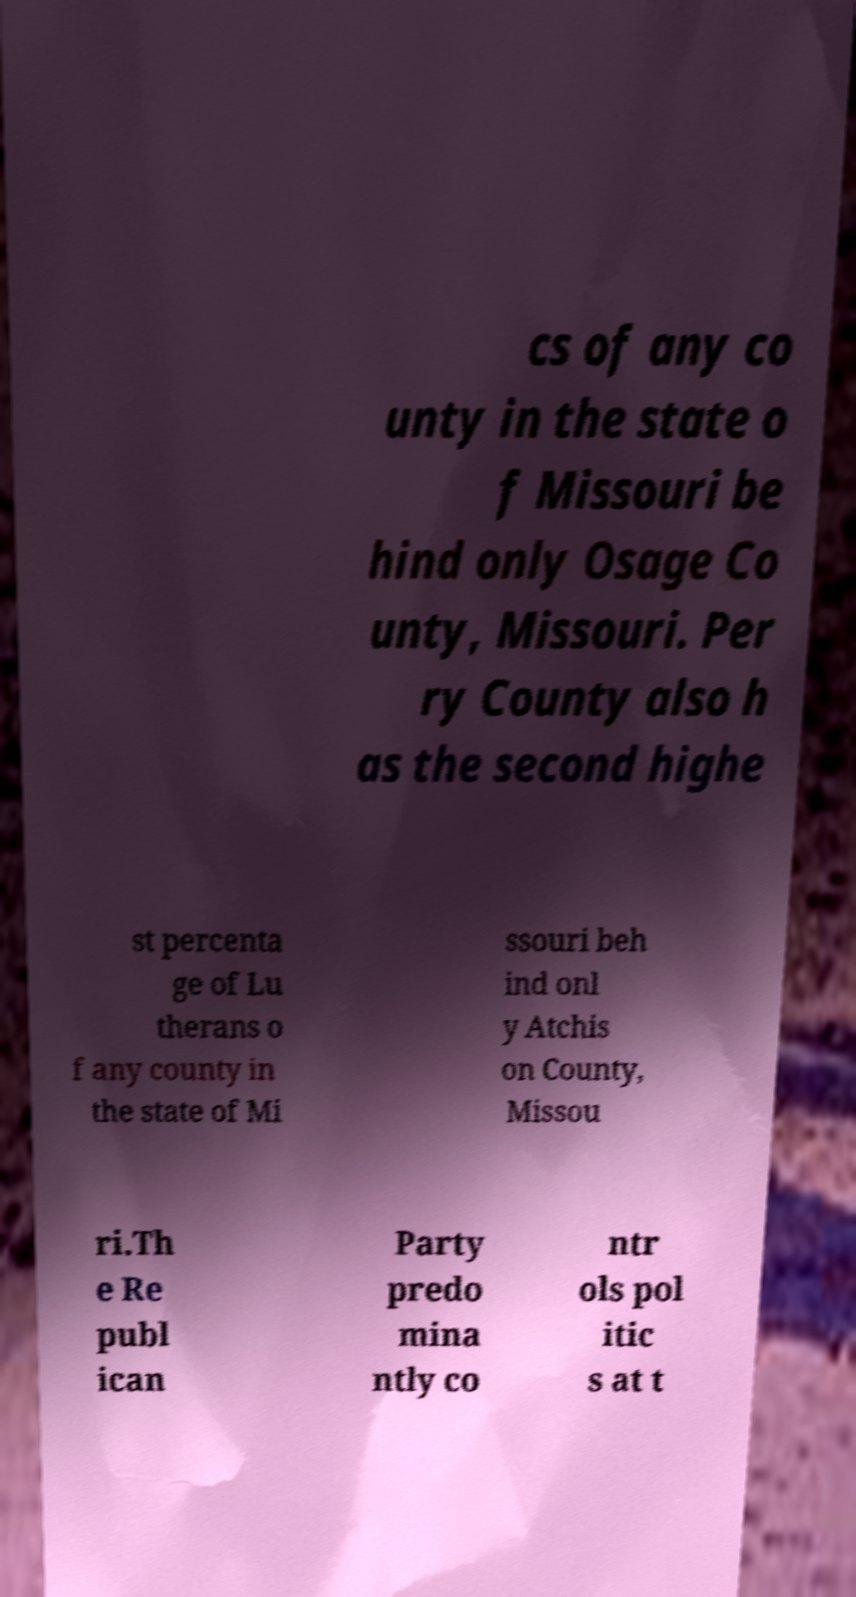Could you extract and type out the text from this image? cs of any co unty in the state o f Missouri be hind only Osage Co unty, Missouri. Per ry County also h as the second highe st percenta ge of Lu therans o f any county in the state of Mi ssouri beh ind onl y Atchis on County, Missou ri.Th e Re publ ican Party predo mina ntly co ntr ols pol itic s at t 